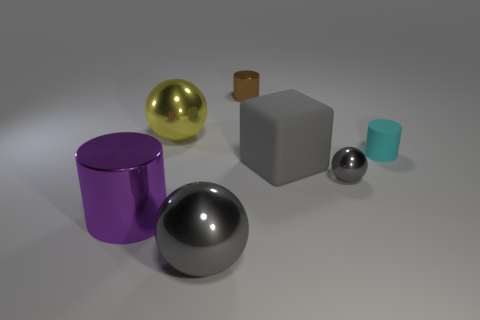Add 2 big gray blocks. How many objects exist? 9 Subtract all cylinders. How many objects are left? 4 Add 3 small cyan cylinders. How many small cyan cylinders are left? 4 Add 3 red objects. How many red objects exist? 3 Subtract 1 gray cubes. How many objects are left? 6 Subtract all big blue shiny blocks. Subtract all rubber cylinders. How many objects are left? 6 